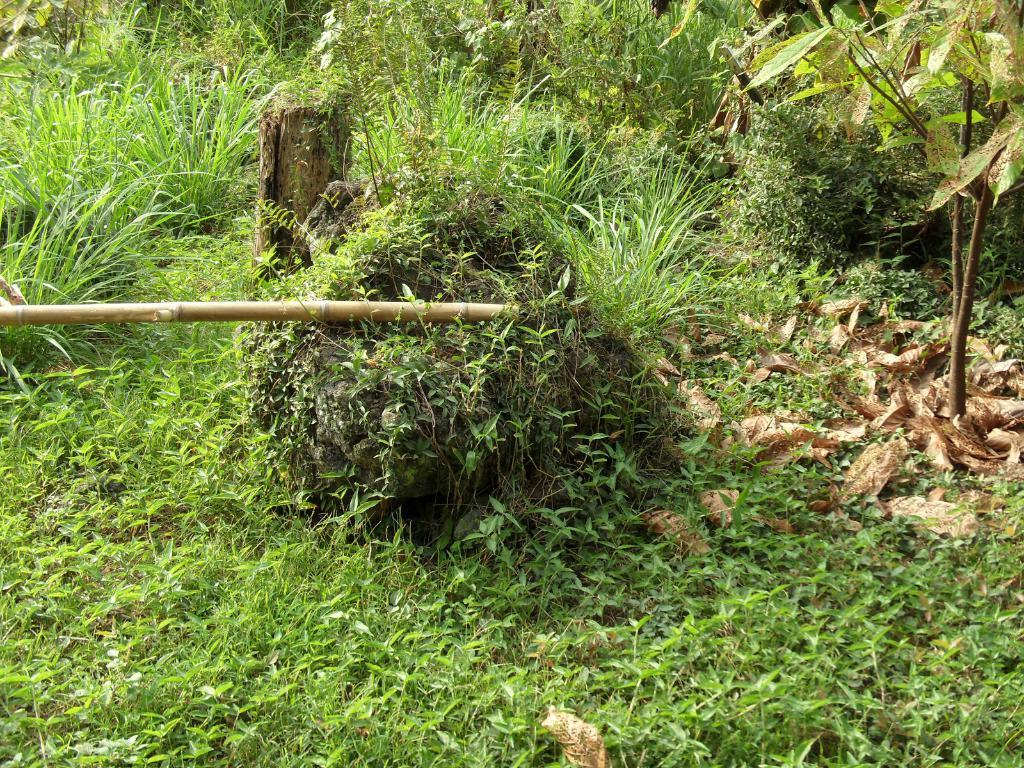What type of vegetation is at the bottom of the image? There is grass at the bottom of the image. What can be seen in the background of the image? There are plants in the background of the image. What object is located on the left side of the image? There is a stick on the left side of the image. What type of sweater is the stranger wearing in the image? There is no stranger or sweater present in the image. What emotion is displayed by the person in the image? There is no person present in the image, so it is impossible to determine their emotions. 